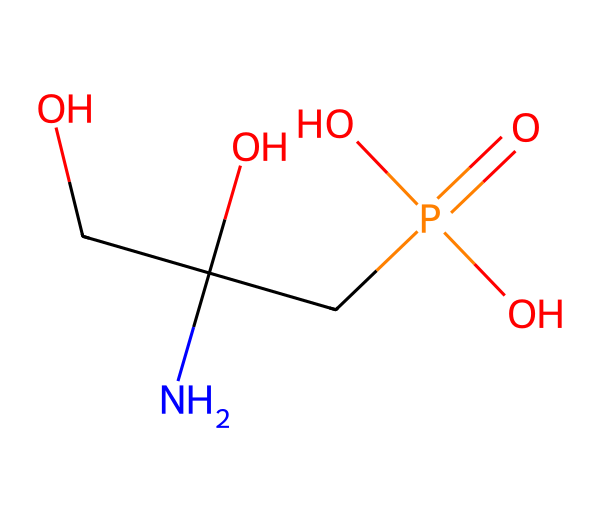What is the main functional group present in glyphosate? The chemical contains a phosphonic acid group, seen by the presence of phosphorus (P) bonded to oxygen (O) and hydroxyl (OH) groups.
Answer: phosphonic acid How many carbon atoms are in glyphosate? Counting from the SMILES representation, there are 2 carbon (C) atoms in the main chain excluding the phosphorus.
Answer: two What is the molecular formula of glyphosate? Analyzing the SMILES shows the presence of 3 carbon (C), 8 hydrogen (H), 1 nitrogen (N), 1 phosphorus (P), and 4 oxygen (O) atoms, leading to the formula C3H8NO5P.
Answer: C3H8NO5P Does glyphosate contain any nitrogen atoms? The presence of an 'N' in the SMILES representation indicates the presence of a nitrogen atom, confirming its existence in the structure.
Answer: yes What property does glyphosate possess that makes it effective as a herbicide? Glyphosate’s phosphonic acid structure allows it to inhibit a specific pathway in plants, making it effective as a herbicide.
Answer: inhibition of plant pathway How many functional groups are present in glyphosate? By analyzing the structure, glyphosate has two distinct functional groups: a phosphonic acid group and an amine group.
Answer: two 